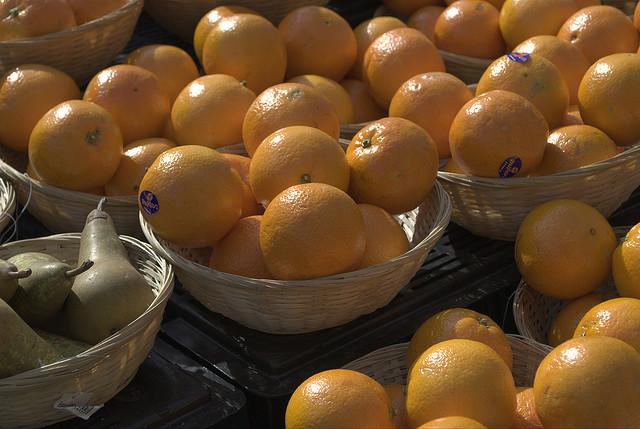What are the tan baskets made out of? straw 